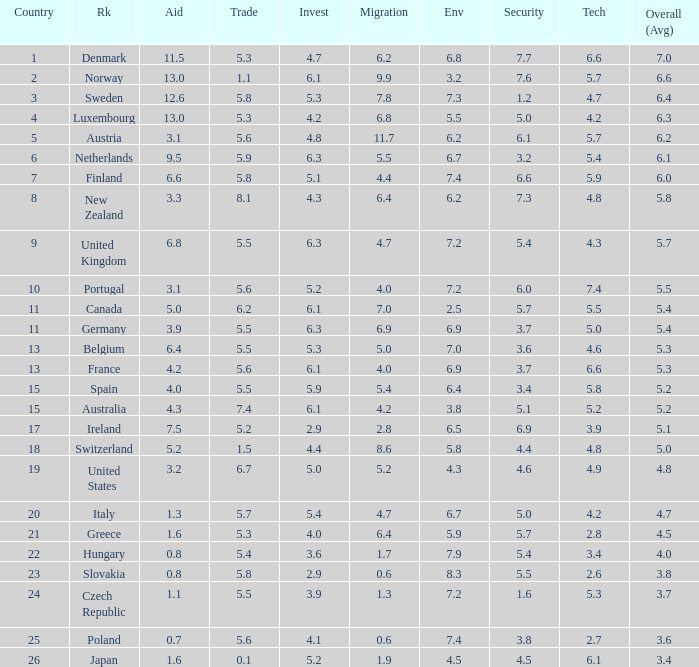What is the environment rating of the country with an overall average rating of 4.7? 6.7. 